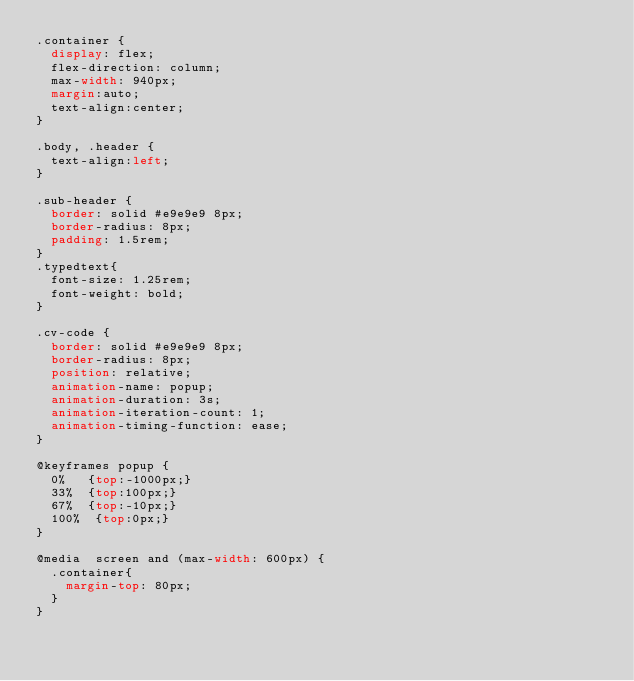Convert code to text. <code><loc_0><loc_0><loc_500><loc_500><_CSS_>.container {
  display: flex;
  flex-direction: column;
  max-width: 940px;
  margin:auto;
  text-align:center;
}

.body, .header {
  text-align:left;
}

.sub-header {
  border: solid #e9e9e9 8px;
  border-radius: 8px;
  padding: 1.5rem;
}
.typedtext{
  font-size: 1.25rem;
  font-weight: bold;
}

.cv-code {
  border: solid #e9e9e9 8px;
  border-radius: 8px;
  position: relative;
  animation-name: popup;
  animation-duration: 3s;
  animation-iteration-count: 1;
  animation-timing-function: ease;
}

@keyframes popup {
  0%   {top:-1000px;}
  33%  {top:100px;}
  67%  {top:-10px;}
  100%  {top:0px;}
}

@media  screen and (max-width: 600px) {
  .container{
    margin-top: 80px;
  }
}
</code> 